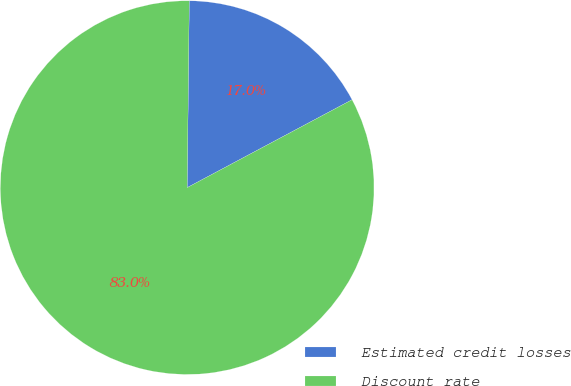Convert chart to OTSL. <chart><loc_0><loc_0><loc_500><loc_500><pie_chart><fcel>Estimated credit losses<fcel>Discount rate<nl><fcel>17.03%<fcel>82.97%<nl></chart> 